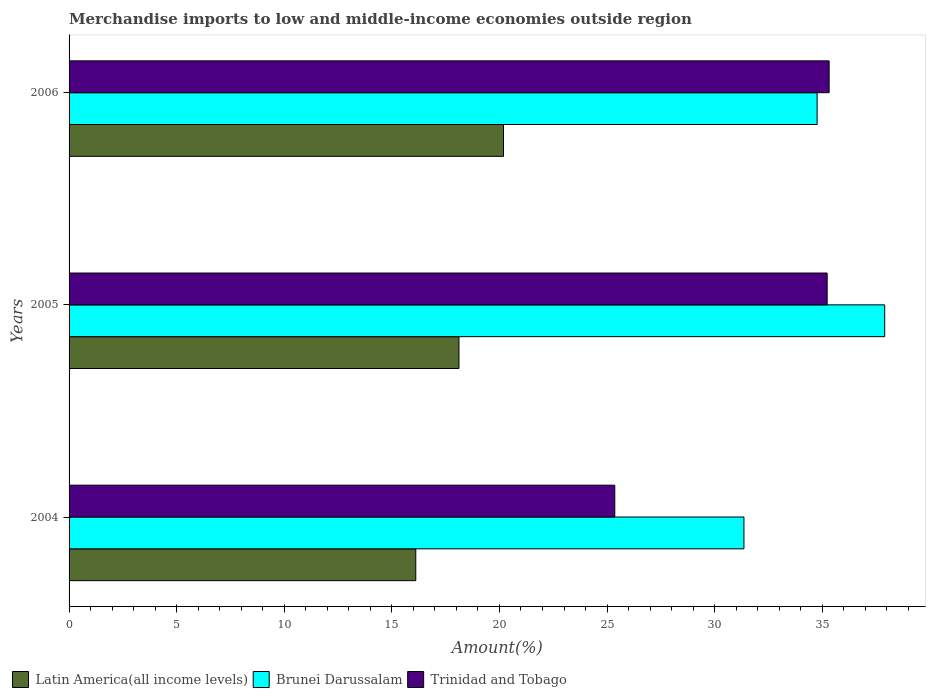How many groups of bars are there?
Your answer should be very brief. 3. Are the number of bars per tick equal to the number of legend labels?
Ensure brevity in your answer.  Yes. Are the number of bars on each tick of the Y-axis equal?
Your answer should be compact. Yes. How many bars are there on the 3rd tick from the top?
Your answer should be very brief. 3. In how many cases, is the number of bars for a given year not equal to the number of legend labels?
Ensure brevity in your answer.  0. What is the percentage of amount earned from merchandise imports in Brunei Darussalam in 2005?
Your response must be concise. 37.9. Across all years, what is the maximum percentage of amount earned from merchandise imports in Brunei Darussalam?
Ensure brevity in your answer.  37.9. Across all years, what is the minimum percentage of amount earned from merchandise imports in Trinidad and Tobago?
Ensure brevity in your answer.  25.36. In which year was the percentage of amount earned from merchandise imports in Latin America(all income levels) maximum?
Provide a short and direct response. 2006. What is the total percentage of amount earned from merchandise imports in Latin America(all income levels) in the graph?
Offer a very short reply. 54.42. What is the difference between the percentage of amount earned from merchandise imports in Trinidad and Tobago in 2004 and that in 2005?
Offer a very short reply. -9.87. What is the difference between the percentage of amount earned from merchandise imports in Latin America(all income levels) in 2004 and the percentage of amount earned from merchandise imports in Brunei Darussalam in 2005?
Make the answer very short. -21.79. What is the average percentage of amount earned from merchandise imports in Brunei Darussalam per year?
Provide a succinct answer. 34.68. In the year 2004, what is the difference between the percentage of amount earned from merchandise imports in Trinidad and Tobago and percentage of amount earned from merchandise imports in Brunei Darussalam?
Give a very brief answer. -6. What is the ratio of the percentage of amount earned from merchandise imports in Latin America(all income levels) in 2004 to that in 2005?
Offer a terse response. 0.89. Is the percentage of amount earned from merchandise imports in Trinidad and Tobago in 2004 less than that in 2005?
Your response must be concise. Yes. Is the difference between the percentage of amount earned from merchandise imports in Trinidad and Tobago in 2004 and 2006 greater than the difference between the percentage of amount earned from merchandise imports in Brunei Darussalam in 2004 and 2006?
Ensure brevity in your answer.  No. What is the difference between the highest and the second highest percentage of amount earned from merchandise imports in Brunei Darussalam?
Your response must be concise. 3.14. What is the difference between the highest and the lowest percentage of amount earned from merchandise imports in Brunei Darussalam?
Your response must be concise. 6.54. Is the sum of the percentage of amount earned from merchandise imports in Latin America(all income levels) in 2004 and 2006 greater than the maximum percentage of amount earned from merchandise imports in Trinidad and Tobago across all years?
Keep it short and to the point. Yes. What does the 1st bar from the top in 2005 represents?
Give a very brief answer. Trinidad and Tobago. What does the 1st bar from the bottom in 2005 represents?
Make the answer very short. Latin America(all income levels). Are all the bars in the graph horizontal?
Offer a terse response. Yes. How many years are there in the graph?
Offer a terse response. 3. What is the difference between two consecutive major ticks on the X-axis?
Your answer should be compact. 5. Are the values on the major ticks of X-axis written in scientific E-notation?
Keep it short and to the point. No. Does the graph contain any zero values?
Provide a succinct answer. No. Does the graph contain grids?
Your answer should be very brief. No. How are the legend labels stacked?
Your answer should be compact. Horizontal. What is the title of the graph?
Ensure brevity in your answer.  Merchandise imports to low and middle-income economies outside region. Does "South Asia" appear as one of the legend labels in the graph?
Offer a terse response. No. What is the label or title of the X-axis?
Offer a very short reply. Amount(%). What is the Amount(%) in Latin America(all income levels) in 2004?
Offer a terse response. 16.11. What is the Amount(%) of Brunei Darussalam in 2004?
Provide a short and direct response. 31.36. What is the Amount(%) in Trinidad and Tobago in 2004?
Offer a terse response. 25.36. What is the Amount(%) of Latin America(all income levels) in 2005?
Ensure brevity in your answer.  18.12. What is the Amount(%) of Brunei Darussalam in 2005?
Keep it short and to the point. 37.9. What is the Amount(%) of Trinidad and Tobago in 2005?
Provide a succinct answer. 35.23. What is the Amount(%) in Latin America(all income levels) in 2006?
Your answer should be very brief. 20.19. What is the Amount(%) of Brunei Darussalam in 2006?
Provide a succinct answer. 34.76. What is the Amount(%) in Trinidad and Tobago in 2006?
Offer a very short reply. 35.32. Across all years, what is the maximum Amount(%) in Latin America(all income levels)?
Make the answer very short. 20.19. Across all years, what is the maximum Amount(%) of Brunei Darussalam?
Offer a very short reply. 37.9. Across all years, what is the maximum Amount(%) in Trinidad and Tobago?
Ensure brevity in your answer.  35.32. Across all years, what is the minimum Amount(%) of Latin America(all income levels)?
Your response must be concise. 16.11. Across all years, what is the minimum Amount(%) of Brunei Darussalam?
Your answer should be very brief. 31.36. Across all years, what is the minimum Amount(%) of Trinidad and Tobago?
Keep it short and to the point. 25.36. What is the total Amount(%) of Latin America(all income levels) in the graph?
Your answer should be very brief. 54.42. What is the total Amount(%) of Brunei Darussalam in the graph?
Give a very brief answer. 104.03. What is the total Amount(%) of Trinidad and Tobago in the graph?
Provide a short and direct response. 95.91. What is the difference between the Amount(%) of Latin America(all income levels) in 2004 and that in 2005?
Your answer should be compact. -2.01. What is the difference between the Amount(%) in Brunei Darussalam in 2004 and that in 2005?
Provide a short and direct response. -6.54. What is the difference between the Amount(%) in Trinidad and Tobago in 2004 and that in 2005?
Keep it short and to the point. -9.87. What is the difference between the Amount(%) of Latin America(all income levels) in 2004 and that in 2006?
Ensure brevity in your answer.  -4.08. What is the difference between the Amount(%) of Brunei Darussalam in 2004 and that in 2006?
Your response must be concise. -3.4. What is the difference between the Amount(%) of Trinidad and Tobago in 2004 and that in 2006?
Provide a short and direct response. -9.96. What is the difference between the Amount(%) of Latin America(all income levels) in 2005 and that in 2006?
Keep it short and to the point. -2.07. What is the difference between the Amount(%) in Brunei Darussalam in 2005 and that in 2006?
Offer a terse response. 3.14. What is the difference between the Amount(%) in Trinidad and Tobago in 2005 and that in 2006?
Make the answer very short. -0.09. What is the difference between the Amount(%) in Latin America(all income levels) in 2004 and the Amount(%) in Brunei Darussalam in 2005?
Keep it short and to the point. -21.79. What is the difference between the Amount(%) of Latin America(all income levels) in 2004 and the Amount(%) of Trinidad and Tobago in 2005?
Give a very brief answer. -19.12. What is the difference between the Amount(%) in Brunei Darussalam in 2004 and the Amount(%) in Trinidad and Tobago in 2005?
Your response must be concise. -3.87. What is the difference between the Amount(%) of Latin America(all income levels) in 2004 and the Amount(%) of Brunei Darussalam in 2006?
Make the answer very short. -18.65. What is the difference between the Amount(%) of Latin America(all income levels) in 2004 and the Amount(%) of Trinidad and Tobago in 2006?
Offer a very short reply. -19.21. What is the difference between the Amount(%) in Brunei Darussalam in 2004 and the Amount(%) in Trinidad and Tobago in 2006?
Keep it short and to the point. -3.96. What is the difference between the Amount(%) of Latin America(all income levels) in 2005 and the Amount(%) of Brunei Darussalam in 2006?
Your response must be concise. -16.64. What is the difference between the Amount(%) of Latin America(all income levels) in 2005 and the Amount(%) of Trinidad and Tobago in 2006?
Ensure brevity in your answer.  -17.2. What is the difference between the Amount(%) of Brunei Darussalam in 2005 and the Amount(%) of Trinidad and Tobago in 2006?
Provide a short and direct response. 2.58. What is the average Amount(%) of Latin America(all income levels) per year?
Provide a short and direct response. 18.14. What is the average Amount(%) in Brunei Darussalam per year?
Provide a succinct answer. 34.68. What is the average Amount(%) in Trinidad and Tobago per year?
Offer a terse response. 31.97. In the year 2004, what is the difference between the Amount(%) of Latin America(all income levels) and Amount(%) of Brunei Darussalam?
Your answer should be very brief. -15.25. In the year 2004, what is the difference between the Amount(%) in Latin America(all income levels) and Amount(%) in Trinidad and Tobago?
Ensure brevity in your answer.  -9.25. In the year 2004, what is the difference between the Amount(%) in Brunei Darussalam and Amount(%) in Trinidad and Tobago?
Provide a succinct answer. 6. In the year 2005, what is the difference between the Amount(%) in Latin America(all income levels) and Amount(%) in Brunei Darussalam?
Keep it short and to the point. -19.78. In the year 2005, what is the difference between the Amount(%) of Latin America(all income levels) and Amount(%) of Trinidad and Tobago?
Offer a very short reply. -17.11. In the year 2005, what is the difference between the Amount(%) of Brunei Darussalam and Amount(%) of Trinidad and Tobago?
Keep it short and to the point. 2.67. In the year 2006, what is the difference between the Amount(%) in Latin America(all income levels) and Amount(%) in Brunei Darussalam?
Ensure brevity in your answer.  -14.57. In the year 2006, what is the difference between the Amount(%) of Latin America(all income levels) and Amount(%) of Trinidad and Tobago?
Make the answer very short. -15.13. In the year 2006, what is the difference between the Amount(%) of Brunei Darussalam and Amount(%) of Trinidad and Tobago?
Keep it short and to the point. -0.56. What is the ratio of the Amount(%) of Latin America(all income levels) in 2004 to that in 2005?
Offer a very short reply. 0.89. What is the ratio of the Amount(%) of Brunei Darussalam in 2004 to that in 2005?
Your response must be concise. 0.83. What is the ratio of the Amount(%) in Trinidad and Tobago in 2004 to that in 2005?
Provide a short and direct response. 0.72. What is the ratio of the Amount(%) of Latin America(all income levels) in 2004 to that in 2006?
Ensure brevity in your answer.  0.8. What is the ratio of the Amount(%) in Brunei Darussalam in 2004 to that in 2006?
Provide a short and direct response. 0.9. What is the ratio of the Amount(%) of Trinidad and Tobago in 2004 to that in 2006?
Keep it short and to the point. 0.72. What is the ratio of the Amount(%) in Latin America(all income levels) in 2005 to that in 2006?
Ensure brevity in your answer.  0.9. What is the ratio of the Amount(%) of Brunei Darussalam in 2005 to that in 2006?
Keep it short and to the point. 1.09. What is the ratio of the Amount(%) of Trinidad and Tobago in 2005 to that in 2006?
Provide a short and direct response. 1. What is the difference between the highest and the second highest Amount(%) in Latin America(all income levels)?
Offer a very short reply. 2.07. What is the difference between the highest and the second highest Amount(%) of Brunei Darussalam?
Offer a very short reply. 3.14. What is the difference between the highest and the second highest Amount(%) of Trinidad and Tobago?
Give a very brief answer. 0.09. What is the difference between the highest and the lowest Amount(%) of Latin America(all income levels)?
Provide a succinct answer. 4.08. What is the difference between the highest and the lowest Amount(%) of Brunei Darussalam?
Make the answer very short. 6.54. What is the difference between the highest and the lowest Amount(%) of Trinidad and Tobago?
Make the answer very short. 9.96. 